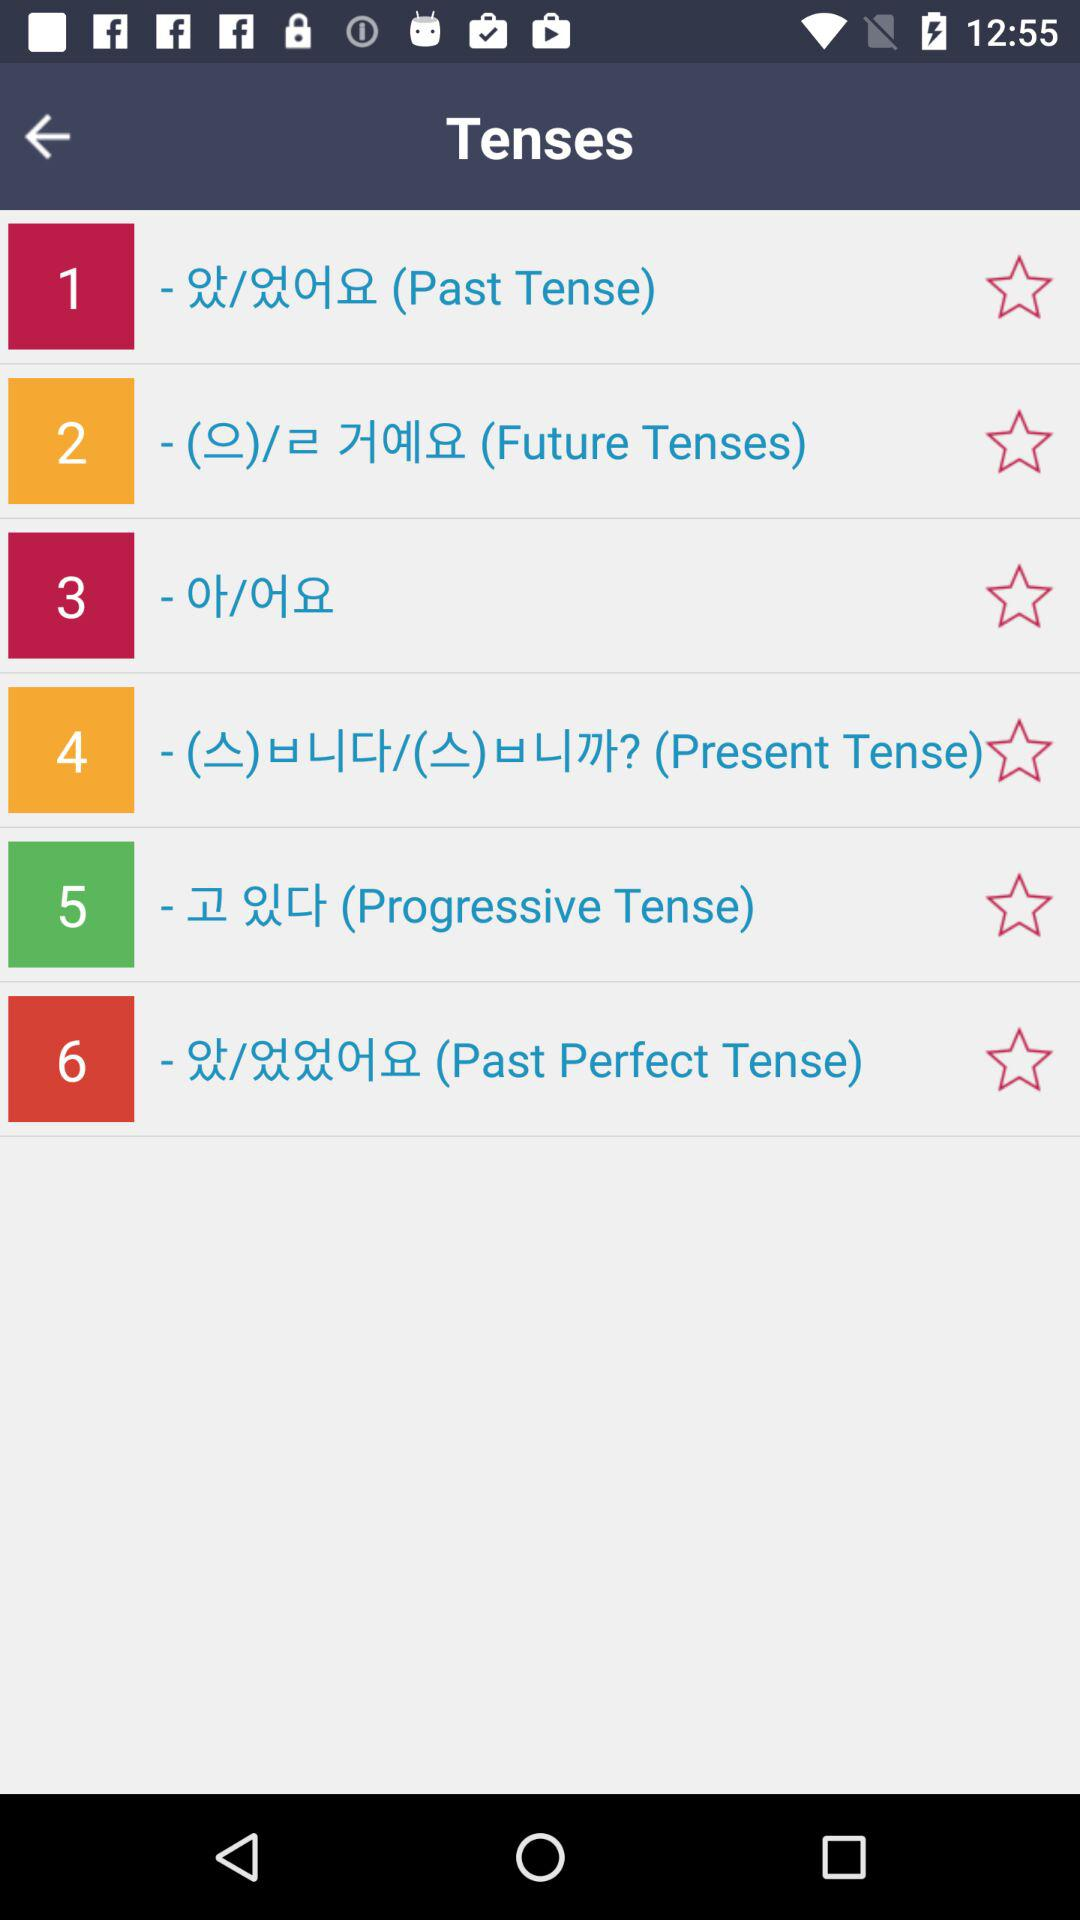What are the types of tenses? The types of tenses are "Past Tense", "Future Tenses", "Present Tense", "Progressive Tense" and "Past Perfect Tense". 